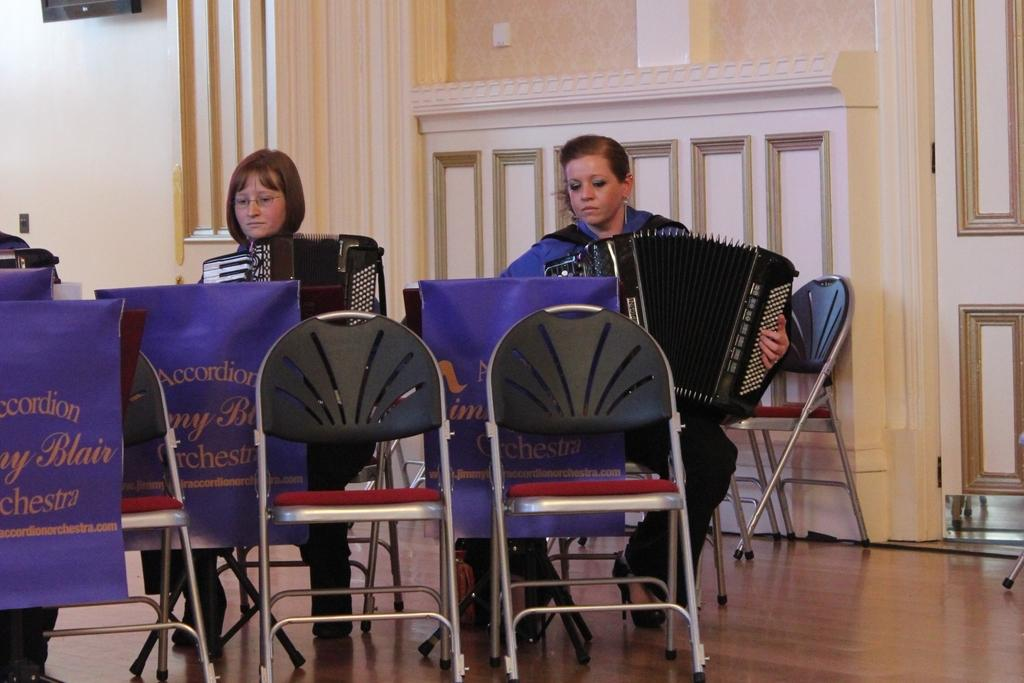How many people are in the image? There are 2 people in the image. What are the people doing in the image? The people are sitting and playing a harmonium. What objects are in front of the people? There are chairs in front of the people. What is visible behind the people? There is a wall behind the people. What color is the crayon that the people are using to draw on the wall? There is no crayon present in the image, and the people are playing a harmonium, not drawing on the wall. 